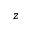<formula> <loc_0><loc_0><loc_500><loc_500>z</formula> 